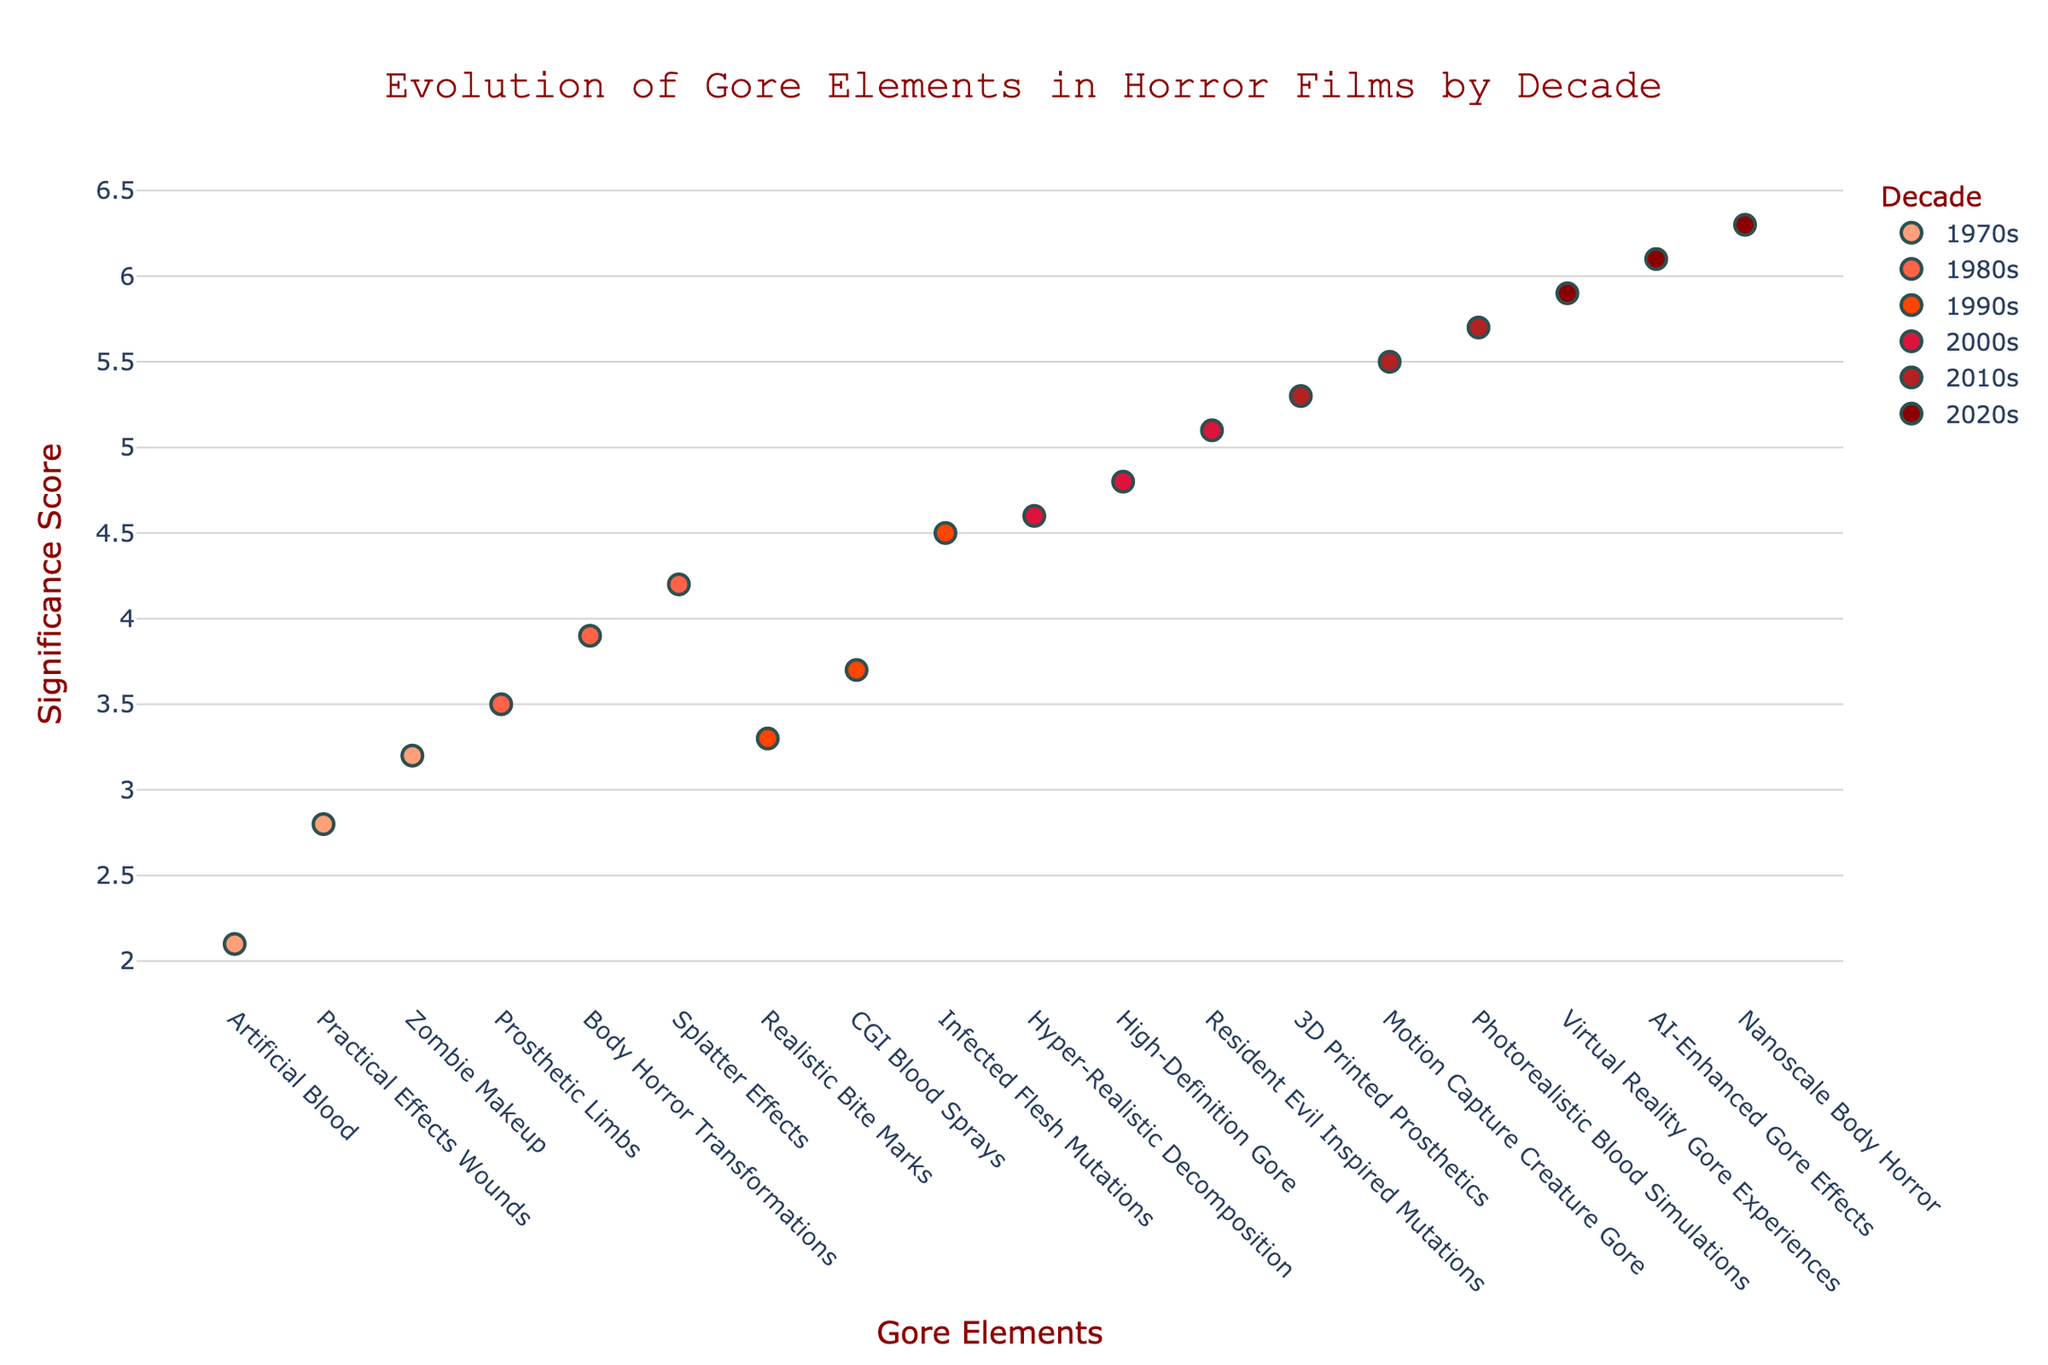What's the title of the figure? The figure's title is displayed prominently at the top in a larger font, usually centered. In our plot, the title text is "Evolution of Gore Elements in Horror Films by Decade."
Answer: Evolution of Gore Elements in Horror Films by Decade How many gore elements are plotted for the 1980s? By observing the graph's legend and looking at the different markers specific to each decade, you can count the number of data points with the color corresponding to the 1980s. In this case, there are three gore elements for the 1980s.
Answer: 3 Which decade shows the highest significance score for any gore element? By scanning the y-axis values and checking the highest point across all decades, we see the highest significance score on the y-axis reaches 6.3 for the 2020s.
Answer: 2020s What is the significance score for "Resident Evil Inspired Mutations" in the 2000s? Locate the 2000s data points and find the specific point labeled "Resident Evil Inspired Mutations." The y-axis value associated with this point gives the significance score, which is 5.1.
Answer: 5.1 Which decade demonstrates the least variation in significance scores among its gore elements? To determine this, observe the spread of data points along the y-axis for each decade. The 1970s show the least variation as the range is narrowest from 2.1 to 3.2 in significance scores.
Answer: 1970s What is the difference in the highest significance scores between the 1990s and the 2020s? Identify the highest significance scores for the 1990s and the 2020s, which are 4.5 and 6.3 respectively. The difference is calculated as 6.3 - 4.5.
Answer: 1.8 How does the significance score of "Photorealistic Blood Simulations" compare to "AI-Enhanced Gore Effects"? Locate these two elements within their respective decades. "Photorealistic Blood Simulations" in the 2010s has a significance score of 5.7, while "AI-Enhanced Gore Effects" in the 2020s has a score of 6.1. Comparing them shows the latter has a higher score.
Answer: AI-Enhanced Gore Effects is higher What trends can you observe in the evolution of gore elements from the 1970s to the 2020s? By examining the plot, you can see a general increase in significance scores over the decades, along with more advanced and diverse gore elements. The y-axis values increment over time, showing a trend towards more graphic content.
Answer: Increasing complexity and significance Which decade introduced 3D Printed Prosthetics and what was its significance score? Locate the data point for "3D Printed Prosthetics" and note the decade it's listed under, which is the 2010s. The significance score associated with it is 5.3.
Answer: 2010s, 5.3 